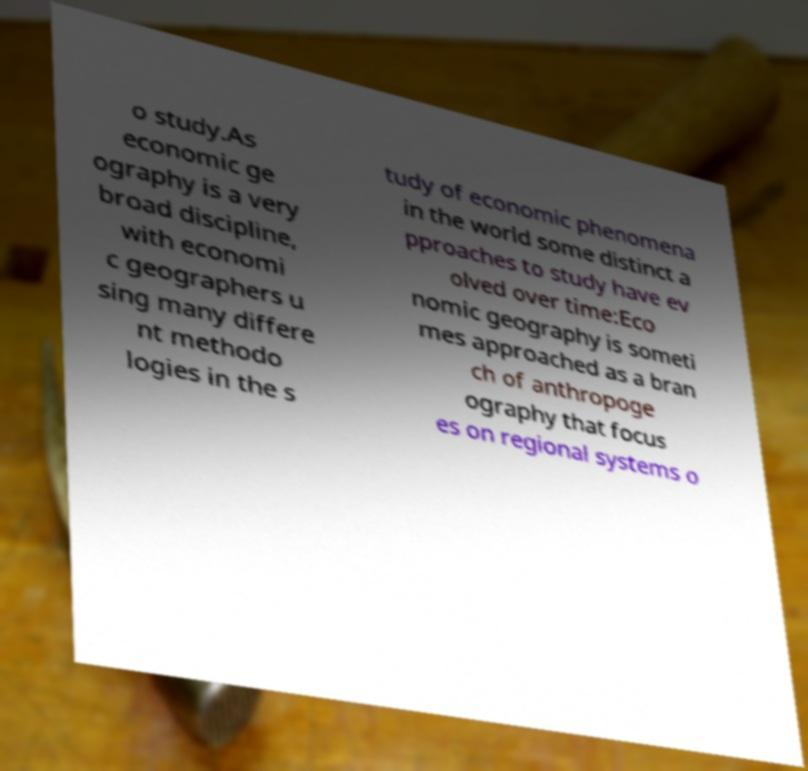Can you accurately transcribe the text from the provided image for me? o study.As economic ge ography is a very broad discipline, with economi c geographers u sing many differe nt methodo logies in the s tudy of economic phenomena in the world some distinct a pproaches to study have ev olved over time:Eco nomic geography is someti mes approached as a bran ch of anthropoge ography that focus es on regional systems o 